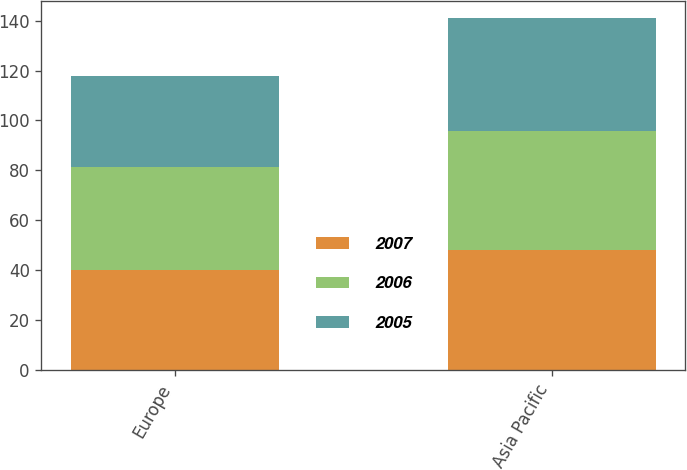Convert chart to OTSL. <chart><loc_0><loc_0><loc_500><loc_500><stacked_bar_chart><ecel><fcel>Europe<fcel>Asia Pacific<nl><fcel>2007<fcel>40<fcel>48.2<nl><fcel>2006<fcel>41.4<fcel>47.5<nl><fcel>2005<fcel>36.3<fcel>45.2<nl></chart> 